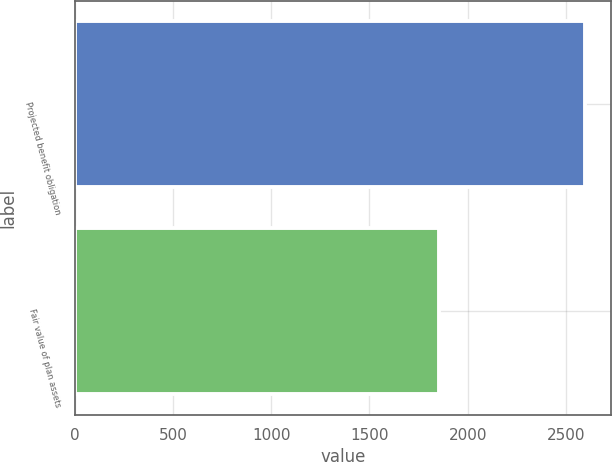<chart> <loc_0><loc_0><loc_500><loc_500><bar_chart><fcel>Projected benefit obligation<fcel>Fair value of plan assets<nl><fcel>2600<fcel>1853<nl></chart> 